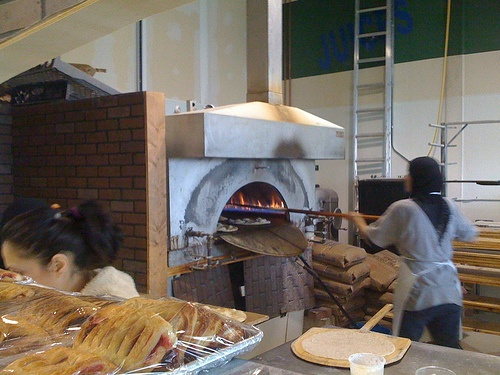Describe the objects in this image and their specific colors. I can see oven in black, gray, and darkgray tones, people in black, gray, and darkgray tones, people in black, gray, tan, and maroon tones, cup in black, lightgray, tan, and darkgray tones, and cup in black, darkgray, gray, and lightgray tones in this image. 